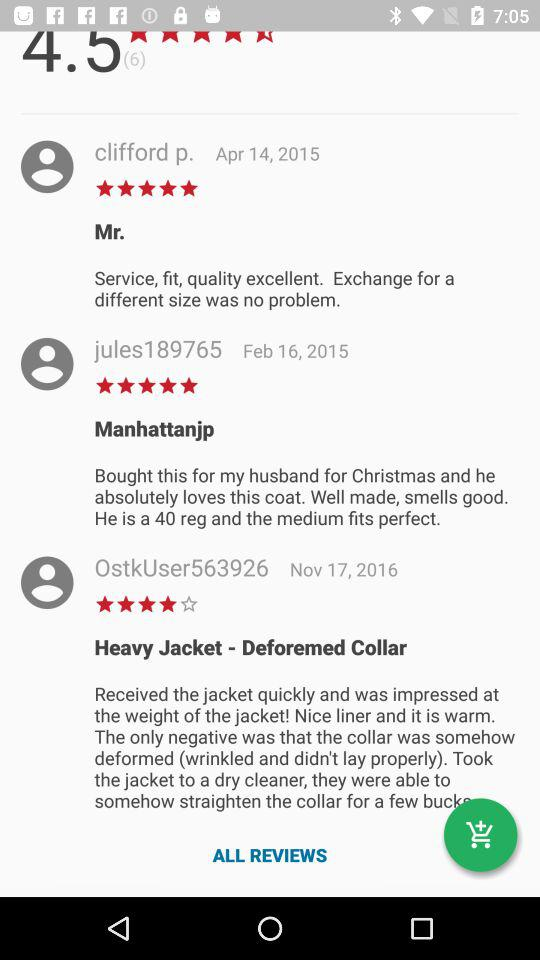Which user wrote a comment on November 17, 2016? The user "OstkUser563926" wrote a comment on November 17, 2016. 